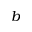Convert formula to latex. <formula><loc_0><loc_0><loc_500><loc_500>b</formula> 